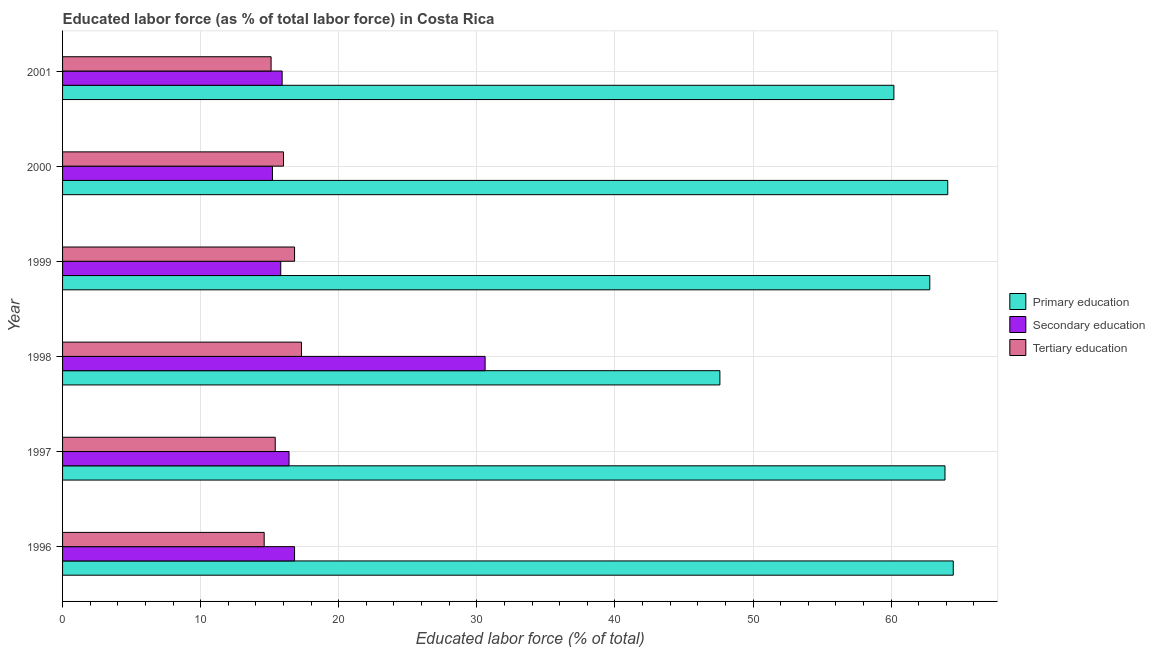How many groups of bars are there?
Ensure brevity in your answer.  6. Are the number of bars on each tick of the Y-axis equal?
Your answer should be compact. Yes. What is the percentage of labor force who received secondary education in 2000?
Offer a very short reply. 15.2. Across all years, what is the maximum percentage of labor force who received secondary education?
Give a very brief answer. 30.6. Across all years, what is the minimum percentage of labor force who received primary education?
Your response must be concise. 47.6. In which year was the percentage of labor force who received primary education maximum?
Your response must be concise. 1996. What is the total percentage of labor force who received tertiary education in the graph?
Your response must be concise. 95.2. What is the difference between the percentage of labor force who received primary education in 1998 and that in 1999?
Your answer should be compact. -15.2. What is the difference between the percentage of labor force who received primary education in 2001 and the percentage of labor force who received tertiary education in 2000?
Give a very brief answer. 44.2. What is the average percentage of labor force who received secondary education per year?
Offer a terse response. 18.45. In the year 1999, what is the difference between the percentage of labor force who received secondary education and percentage of labor force who received tertiary education?
Ensure brevity in your answer.  -1. What is the ratio of the percentage of labor force who received tertiary education in 1996 to that in 1997?
Your answer should be very brief. 0.95. Is the difference between the percentage of labor force who received primary education in 1997 and 2001 greater than the difference between the percentage of labor force who received tertiary education in 1997 and 2001?
Give a very brief answer. Yes. What is the difference between the highest and the second highest percentage of labor force who received tertiary education?
Ensure brevity in your answer.  0.5. What is the difference between the highest and the lowest percentage of labor force who received primary education?
Provide a short and direct response. 16.9. Is the sum of the percentage of labor force who received secondary education in 1996 and 1999 greater than the maximum percentage of labor force who received primary education across all years?
Your answer should be very brief. No. What does the 2nd bar from the top in 1997 represents?
Give a very brief answer. Secondary education. What does the 3rd bar from the bottom in 1998 represents?
Your answer should be compact. Tertiary education. Are the values on the major ticks of X-axis written in scientific E-notation?
Provide a short and direct response. No. Does the graph contain any zero values?
Give a very brief answer. No. Does the graph contain grids?
Ensure brevity in your answer.  Yes. What is the title of the graph?
Offer a very short reply. Educated labor force (as % of total labor force) in Costa Rica. Does "Renewable sources" appear as one of the legend labels in the graph?
Ensure brevity in your answer.  No. What is the label or title of the X-axis?
Your answer should be compact. Educated labor force (% of total). What is the Educated labor force (% of total) of Primary education in 1996?
Offer a terse response. 64.5. What is the Educated labor force (% of total) in Secondary education in 1996?
Make the answer very short. 16.8. What is the Educated labor force (% of total) of Tertiary education in 1996?
Your answer should be very brief. 14.6. What is the Educated labor force (% of total) in Primary education in 1997?
Give a very brief answer. 63.9. What is the Educated labor force (% of total) in Secondary education in 1997?
Make the answer very short. 16.4. What is the Educated labor force (% of total) of Tertiary education in 1997?
Make the answer very short. 15.4. What is the Educated labor force (% of total) in Primary education in 1998?
Offer a terse response. 47.6. What is the Educated labor force (% of total) in Secondary education in 1998?
Offer a terse response. 30.6. What is the Educated labor force (% of total) in Tertiary education in 1998?
Your answer should be compact. 17.3. What is the Educated labor force (% of total) in Primary education in 1999?
Keep it short and to the point. 62.8. What is the Educated labor force (% of total) in Secondary education in 1999?
Give a very brief answer. 15.8. What is the Educated labor force (% of total) in Tertiary education in 1999?
Provide a short and direct response. 16.8. What is the Educated labor force (% of total) in Primary education in 2000?
Provide a succinct answer. 64.1. What is the Educated labor force (% of total) in Secondary education in 2000?
Offer a very short reply. 15.2. What is the Educated labor force (% of total) of Tertiary education in 2000?
Keep it short and to the point. 16. What is the Educated labor force (% of total) of Primary education in 2001?
Provide a succinct answer. 60.2. What is the Educated labor force (% of total) in Secondary education in 2001?
Keep it short and to the point. 15.9. What is the Educated labor force (% of total) in Tertiary education in 2001?
Provide a short and direct response. 15.1. Across all years, what is the maximum Educated labor force (% of total) in Primary education?
Offer a very short reply. 64.5. Across all years, what is the maximum Educated labor force (% of total) of Secondary education?
Your answer should be compact. 30.6. Across all years, what is the maximum Educated labor force (% of total) of Tertiary education?
Your answer should be compact. 17.3. Across all years, what is the minimum Educated labor force (% of total) in Primary education?
Offer a very short reply. 47.6. Across all years, what is the minimum Educated labor force (% of total) of Secondary education?
Keep it short and to the point. 15.2. Across all years, what is the minimum Educated labor force (% of total) in Tertiary education?
Make the answer very short. 14.6. What is the total Educated labor force (% of total) in Primary education in the graph?
Offer a terse response. 363.1. What is the total Educated labor force (% of total) in Secondary education in the graph?
Your answer should be very brief. 110.7. What is the total Educated labor force (% of total) of Tertiary education in the graph?
Keep it short and to the point. 95.2. What is the difference between the Educated labor force (% of total) of Primary education in 1996 and that in 1997?
Your answer should be compact. 0.6. What is the difference between the Educated labor force (% of total) in Secondary education in 1996 and that in 1997?
Keep it short and to the point. 0.4. What is the difference between the Educated labor force (% of total) of Tertiary education in 1996 and that in 1997?
Make the answer very short. -0.8. What is the difference between the Educated labor force (% of total) of Secondary education in 1996 and that in 1998?
Give a very brief answer. -13.8. What is the difference between the Educated labor force (% of total) of Primary education in 1996 and that in 2000?
Your answer should be very brief. 0.4. What is the difference between the Educated labor force (% of total) in Secondary education in 1996 and that in 2000?
Give a very brief answer. 1.6. What is the difference between the Educated labor force (% of total) in Primary education in 1996 and that in 2001?
Provide a short and direct response. 4.3. What is the difference between the Educated labor force (% of total) of Secondary education in 1996 and that in 2001?
Keep it short and to the point. 0.9. What is the difference between the Educated labor force (% of total) in Tertiary education in 1997 and that in 1998?
Offer a terse response. -1.9. What is the difference between the Educated labor force (% of total) in Primary education in 1997 and that in 2001?
Provide a short and direct response. 3.7. What is the difference between the Educated labor force (% of total) in Primary education in 1998 and that in 1999?
Your response must be concise. -15.2. What is the difference between the Educated labor force (% of total) of Secondary education in 1998 and that in 1999?
Provide a succinct answer. 14.8. What is the difference between the Educated labor force (% of total) of Tertiary education in 1998 and that in 1999?
Your response must be concise. 0.5. What is the difference between the Educated labor force (% of total) in Primary education in 1998 and that in 2000?
Offer a very short reply. -16.5. What is the difference between the Educated labor force (% of total) in Secondary education in 1998 and that in 2000?
Give a very brief answer. 15.4. What is the difference between the Educated labor force (% of total) in Tertiary education in 1998 and that in 2000?
Offer a very short reply. 1.3. What is the difference between the Educated labor force (% of total) in Primary education in 1998 and that in 2001?
Offer a terse response. -12.6. What is the difference between the Educated labor force (% of total) in Secondary education in 1998 and that in 2001?
Ensure brevity in your answer.  14.7. What is the difference between the Educated labor force (% of total) in Tertiary education in 1998 and that in 2001?
Your answer should be very brief. 2.2. What is the difference between the Educated labor force (% of total) in Primary education in 1999 and that in 2000?
Make the answer very short. -1.3. What is the difference between the Educated labor force (% of total) in Secondary education in 1999 and that in 2000?
Offer a terse response. 0.6. What is the difference between the Educated labor force (% of total) of Tertiary education in 1999 and that in 2000?
Offer a terse response. 0.8. What is the difference between the Educated labor force (% of total) in Primary education in 1999 and that in 2001?
Your answer should be compact. 2.6. What is the difference between the Educated labor force (% of total) of Secondary education in 1999 and that in 2001?
Provide a succinct answer. -0.1. What is the difference between the Educated labor force (% of total) of Tertiary education in 1999 and that in 2001?
Your response must be concise. 1.7. What is the difference between the Educated labor force (% of total) in Primary education in 2000 and that in 2001?
Offer a very short reply. 3.9. What is the difference between the Educated labor force (% of total) of Secondary education in 2000 and that in 2001?
Make the answer very short. -0.7. What is the difference between the Educated labor force (% of total) of Primary education in 1996 and the Educated labor force (% of total) of Secondary education in 1997?
Offer a terse response. 48.1. What is the difference between the Educated labor force (% of total) in Primary education in 1996 and the Educated labor force (% of total) in Tertiary education in 1997?
Your answer should be compact. 49.1. What is the difference between the Educated labor force (% of total) in Secondary education in 1996 and the Educated labor force (% of total) in Tertiary education in 1997?
Provide a short and direct response. 1.4. What is the difference between the Educated labor force (% of total) of Primary education in 1996 and the Educated labor force (% of total) of Secondary education in 1998?
Provide a short and direct response. 33.9. What is the difference between the Educated labor force (% of total) in Primary education in 1996 and the Educated labor force (% of total) in Tertiary education in 1998?
Ensure brevity in your answer.  47.2. What is the difference between the Educated labor force (% of total) of Primary education in 1996 and the Educated labor force (% of total) of Secondary education in 1999?
Make the answer very short. 48.7. What is the difference between the Educated labor force (% of total) of Primary education in 1996 and the Educated labor force (% of total) of Tertiary education in 1999?
Keep it short and to the point. 47.7. What is the difference between the Educated labor force (% of total) in Primary education in 1996 and the Educated labor force (% of total) in Secondary education in 2000?
Your response must be concise. 49.3. What is the difference between the Educated labor force (% of total) of Primary education in 1996 and the Educated labor force (% of total) of Tertiary education in 2000?
Your response must be concise. 48.5. What is the difference between the Educated labor force (% of total) in Secondary education in 1996 and the Educated labor force (% of total) in Tertiary education in 2000?
Your answer should be very brief. 0.8. What is the difference between the Educated labor force (% of total) in Primary education in 1996 and the Educated labor force (% of total) in Secondary education in 2001?
Your response must be concise. 48.6. What is the difference between the Educated labor force (% of total) in Primary education in 1996 and the Educated labor force (% of total) in Tertiary education in 2001?
Keep it short and to the point. 49.4. What is the difference between the Educated labor force (% of total) in Primary education in 1997 and the Educated labor force (% of total) in Secondary education in 1998?
Provide a short and direct response. 33.3. What is the difference between the Educated labor force (% of total) of Primary education in 1997 and the Educated labor force (% of total) of Tertiary education in 1998?
Give a very brief answer. 46.6. What is the difference between the Educated labor force (% of total) in Secondary education in 1997 and the Educated labor force (% of total) in Tertiary education in 1998?
Your answer should be compact. -0.9. What is the difference between the Educated labor force (% of total) of Primary education in 1997 and the Educated labor force (% of total) of Secondary education in 1999?
Your response must be concise. 48.1. What is the difference between the Educated labor force (% of total) of Primary education in 1997 and the Educated labor force (% of total) of Tertiary education in 1999?
Ensure brevity in your answer.  47.1. What is the difference between the Educated labor force (% of total) in Primary education in 1997 and the Educated labor force (% of total) in Secondary education in 2000?
Offer a very short reply. 48.7. What is the difference between the Educated labor force (% of total) in Primary education in 1997 and the Educated labor force (% of total) in Tertiary education in 2000?
Offer a terse response. 47.9. What is the difference between the Educated labor force (% of total) of Secondary education in 1997 and the Educated labor force (% of total) of Tertiary education in 2000?
Your response must be concise. 0.4. What is the difference between the Educated labor force (% of total) of Primary education in 1997 and the Educated labor force (% of total) of Secondary education in 2001?
Keep it short and to the point. 48. What is the difference between the Educated labor force (% of total) of Primary education in 1997 and the Educated labor force (% of total) of Tertiary education in 2001?
Make the answer very short. 48.8. What is the difference between the Educated labor force (% of total) of Secondary education in 1997 and the Educated labor force (% of total) of Tertiary education in 2001?
Provide a short and direct response. 1.3. What is the difference between the Educated labor force (% of total) in Primary education in 1998 and the Educated labor force (% of total) in Secondary education in 1999?
Your answer should be very brief. 31.8. What is the difference between the Educated labor force (% of total) of Primary education in 1998 and the Educated labor force (% of total) of Tertiary education in 1999?
Keep it short and to the point. 30.8. What is the difference between the Educated labor force (% of total) of Primary education in 1998 and the Educated labor force (% of total) of Secondary education in 2000?
Offer a very short reply. 32.4. What is the difference between the Educated labor force (% of total) of Primary education in 1998 and the Educated labor force (% of total) of Tertiary education in 2000?
Make the answer very short. 31.6. What is the difference between the Educated labor force (% of total) in Secondary education in 1998 and the Educated labor force (% of total) in Tertiary education in 2000?
Ensure brevity in your answer.  14.6. What is the difference between the Educated labor force (% of total) of Primary education in 1998 and the Educated labor force (% of total) of Secondary education in 2001?
Give a very brief answer. 31.7. What is the difference between the Educated labor force (% of total) in Primary education in 1998 and the Educated labor force (% of total) in Tertiary education in 2001?
Your answer should be compact. 32.5. What is the difference between the Educated labor force (% of total) of Secondary education in 1998 and the Educated labor force (% of total) of Tertiary education in 2001?
Offer a very short reply. 15.5. What is the difference between the Educated labor force (% of total) in Primary education in 1999 and the Educated labor force (% of total) in Secondary education in 2000?
Give a very brief answer. 47.6. What is the difference between the Educated labor force (% of total) of Primary education in 1999 and the Educated labor force (% of total) of Tertiary education in 2000?
Your response must be concise. 46.8. What is the difference between the Educated labor force (% of total) of Secondary education in 1999 and the Educated labor force (% of total) of Tertiary education in 2000?
Your answer should be very brief. -0.2. What is the difference between the Educated labor force (% of total) of Primary education in 1999 and the Educated labor force (% of total) of Secondary education in 2001?
Ensure brevity in your answer.  46.9. What is the difference between the Educated labor force (% of total) in Primary education in 1999 and the Educated labor force (% of total) in Tertiary education in 2001?
Your answer should be very brief. 47.7. What is the difference between the Educated labor force (% of total) in Secondary education in 1999 and the Educated labor force (% of total) in Tertiary education in 2001?
Your answer should be very brief. 0.7. What is the difference between the Educated labor force (% of total) of Primary education in 2000 and the Educated labor force (% of total) of Secondary education in 2001?
Your response must be concise. 48.2. What is the difference between the Educated labor force (% of total) of Primary education in 2000 and the Educated labor force (% of total) of Tertiary education in 2001?
Provide a succinct answer. 49. What is the average Educated labor force (% of total) of Primary education per year?
Provide a succinct answer. 60.52. What is the average Educated labor force (% of total) of Secondary education per year?
Your response must be concise. 18.45. What is the average Educated labor force (% of total) of Tertiary education per year?
Offer a very short reply. 15.87. In the year 1996, what is the difference between the Educated labor force (% of total) in Primary education and Educated labor force (% of total) in Secondary education?
Make the answer very short. 47.7. In the year 1996, what is the difference between the Educated labor force (% of total) in Primary education and Educated labor force (% of total) in Tertiary education?
Provide a short and direct response. 49.9. In the year 1996, what is the difference between the Educated labor force (% of total) in Secondary education and Educated labor force (% of total) in Tertiary education?
Offer a very short reply. 2.2. In the year 1997, what is the difference between the Educated labor force (% of total) of Primary education and Educated labor force (% of total) of Secondary education?
Offer a terse response. 47.5. In the year 1997, what is the difference between the Educated labor force (% of total) of Primary education and Educated labor force (% of total) of Tertiary education?
Ensure brevity in your answer.  48.5. In the year 1997, what is the difference between the Educated labor force (% of total) of Secondary education and Educated labor force (% of total) of Tertiary education?
Make the answer very short. 1. In the year 1998, what is the difference between the Educated labor force (% of total) in Primary education and Educated labor force (% of total) in Secondary education?
Your response must be concise. 17. In the year 1998, what is the difference between the Educated labor force (% of total) of Primary education and Educated labor force (% of total) of Tertiary education?
Provide a succinct answer. 30.3. In the year 1998, what is the difference between the Educated labor force (% of total) in Secondary education and Educated labor force (% of total) in Tertiary education?
Provide a succinct answer. 13.3. In the year 1999, what is the difference between the Educated labor force (% of total) in Primary education and Educated labor force (% of total) in Secondary education?
Keep it short and to the point. 47. In the year 1999, what is the difference between the Educated labor force (% of total) of Primary education and Educated labor force (% of total) of Tertiary education?
Make the answer very short. 46. In the year 1999, what is the difference between the Educated labor force (% of total) of Secondary education and Educated labor force (% of total) of Tertiary education?
Make the answer very short. -1. In the year 2000, what is the difference between the Educated labor force (% of total) of Primary education and Educated labor force (% of total) of Secondary education?
Your answer should be compact. 48.9. In the year 2000, what is the difference between the Educated labor force (% of total) of Primary education and Educated labor force (% of total) of Tertiary education?
Your answer should be compact. 48.1. In the year 2001, what is the difference between the Educated labor force (% of total) of Primary education and Educated labor force (% of total) of Secondary education?
Make the answer very short. 44.3. In the year 2001, what is the difference between the Educated labor force (% of total) in Primary education and Educated labor force (% of total) in Tertiary education?
Provide a succinct answer. 45.1. In the year 2001, what is the difference between the Educated labor force (% of total) in Secondary education and Educated labor force (% of total) in Tertiary education?
Provide a short and direct response. 0.8. What is the ratio of the Educated labor force (% of total) of Primary education in 1996 to that in 1997?
Your answer should be very brief. 1.01. What is the ratio of the Educated labor force (% of total) of Secondary education in 1996 to that in 1997?
Offer a terse response. 1.02. What is the ratio of the Educated labor force (% of total) of Tertiary education in 1996 to that in 1997?
Ensure brevity in your answer.  0.95. What is the ratio of the Educated labor force (% of total) in Primary education in 1996 to that in 1998?
Your answer should be compact. 1.35. What is the ratio of the Educated labor force (% of total) in Secondary education in 1996 to that in 1998?
Provide a succinct answer. 0.55. What is the ratio of the Educated labor force (% of total) in Tertiary education in 1996 to that in 1998?
Give a very brief answer. 0.84. What is the ratio of the Educated labor force (% of total) of Primary education in 1996 to that in 1999?
Provide a succinct answer. 1.03. What is the ratio of the Educated labor force (% of total) in Secondary education in 1996 to that in 1999?
Provide a short and direct response. 1.06. What is the ratio of the Educated labor force (% of total) of Tertiary education in 1996 to that in 1999?
Keep it short and to the point. 0.87. What is the ratio of the Educated labor force (% of total) in Primary education in 1996 to that in 2000?
Offer a very short reply. 1.01. What is the ratio of the Educated labor force (% of total) of Secondary education in 1996 to that in 2000?
Your response must be concise. 1.11. What is the ratio of the Educated labor force (% of total) of Tertiary education in 1996 to that in 2000?
Your answer should be very brief. 0.91. What is the ratio of the Educated labor force (% of total) of Primary education in 1996 to that in 2001?
Your answer should be very brief. 1.07. What is the ratio of the Educated labor force (% of total) of Secondary education in 1996 to that in 2001?
Provide a succinct answer. 1.06. What is the ratio of the Educated labor force (% of total) in Tertiary education in 1996 to that in 2001?
Your response must be concise. 0.97. What is the ratio of the Educated labor force (% of total) in Primary education in 1997 to that in 1998?
Your response must be concise. 1.34. What is the ratio of the Educated labor force (% of total) of Secondary education in 1997 to that in 1998?
Ensure brevity in your answer.  0.54. What is the ratio of the Educated labor force (% of total) of Tertiary education in 1997 to that in 1998?
Your answer should be compact. 0.89. What is the ratio of the Educated labor force (% of total) of Primary education in 1997 to that in 1999?
Your response must be concise. 1.02. What is the ratio of the Educated labor force (% of total) of Secondary education in 1997 to that in 1999?
Your answer should be compact. 1.04. What is the ratio of the Educated labor force (% of total) of Tertiary education in 1997 to that in 1999?
Offer a very short reply. 0.92. What is the ratio of the Educated labor force (% of total) in Secondary education in 1997 to that in 2000?
Give a very brief answer. 1.08. What is the ratio of the Educated labor force (% of total) of Tertiary education in 1997 to that in 2000?
Give a very brief answer. 0.96. What is the ratio of the Educated labor force (% of total) of Primary education in 1997 to that in 2001?
Give a very brief answer. 1.06. What is the ratio of the Educated labor force (% of total) of Secondary education in 1997 to that in 2001?
Provide a short and direct response. 1.03. What is the ratio of the Educated labor force (% of total) in Tertiary education in 1997 to that in 2001?
Your answer should be very brief. 1.02. What is the ratio of the Educated labor force (% of total) of Primary education in 1998 to that in 1999?
Ensure brevity in your answer.  0.76. What is the ratio of the Educated labor force (% of total) of Secondary education in 1998 to that in 1999?
Offer a very short reply. 1.94. What is the ratio of the Educated labor force (% of total) in Tertiary education in 1998 to that in 1999?
Make the answer very short. 1.03. What is the ratio of the Educated labor force (% of total) in Primary education in 1998 to that in 2000?
Provide a succinct answer. 0.74. What is the ratio of the Educated labor force (% of total) in Secondary education in 1998 to that in 2000?
Give a very brief answer. 2.01. What is the ratio of the Educated labor force (% of total) of Tertiary education in 1998 to that in 2000?
Give a very brief answer. 1.08. What is the ratio of the Educated labor force (% of total) in Primary education in 1998 to that in 2001?
Offer a very short reply. 0.79. What is the ratio of the Educated labor force (% of total) in Secondary education in 1998 to that in 2001?
Make the answer very short. 1.92. What is the ratio of the Educated labor force (% of total) of Tertiary education in 1998 to that in 2001?
Keep it short and to the point. 1.15. What is the ratio of the Educated labor force (% of total) of Primary education in 1999 to that in 2000?
Your answer should be very brief. 0.98. What is the ratio of the Educated labor force (% of total) of Secondary education in 1999 to that in 2000?
Make the answer very short. 1.04. What is the ratio of the Educated labor force (% of total) of Tertiary education in 1999 to that in 2000?
Make the answer very short. 1.05. What is the ratio of the Educated labor force (% of total) of Primary education in 1999 to that in 2001?
Provide a short and direct response. 1.04. What is the ratio of the Educated labor force (% of total) of Secondary education in 1999 to that in 2001?
Your answer should be compact. 0.99. What is the ratio of the Educated labor force (% of total) of Tertiary education in 1999 to that in 2001?
Make the answer very short. 1.11. What is the ratio of the Educated labor force (% of total) of Primary education in 2000 to that in 2001?
Offer a very short reply. 1.06. What is the ratio of the Educated labor force (% of total) in Secondary education in 2000 to that in 2001?
Make the answer very short. 0.96. What is the ratio of the Educated labor force (% of total) in Tertiary education in 2000 to that in 2001?
Provide a short and direct response. 1.06. What is the difference between the highest and the second highest Educated labor force (% of total) of Primary education?
Offer a very short reply. 0.4. 